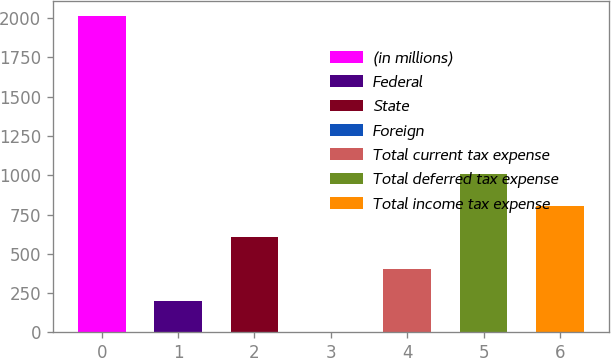<chart> <loc_0><loc_0><loc_500><loc_500><bar_chart><fcel>(in millions)<fcel>Federal<fcel>State<fcel>Foreign<fcel>Total current tax expense<fcel>Total deferred tax expense<fcel>Total income tax expense<nl><fcel>2011<fcel>202<fcel>604<fcel>1<fcel>403<fcel>1006<fcel>805<nl></chart> 